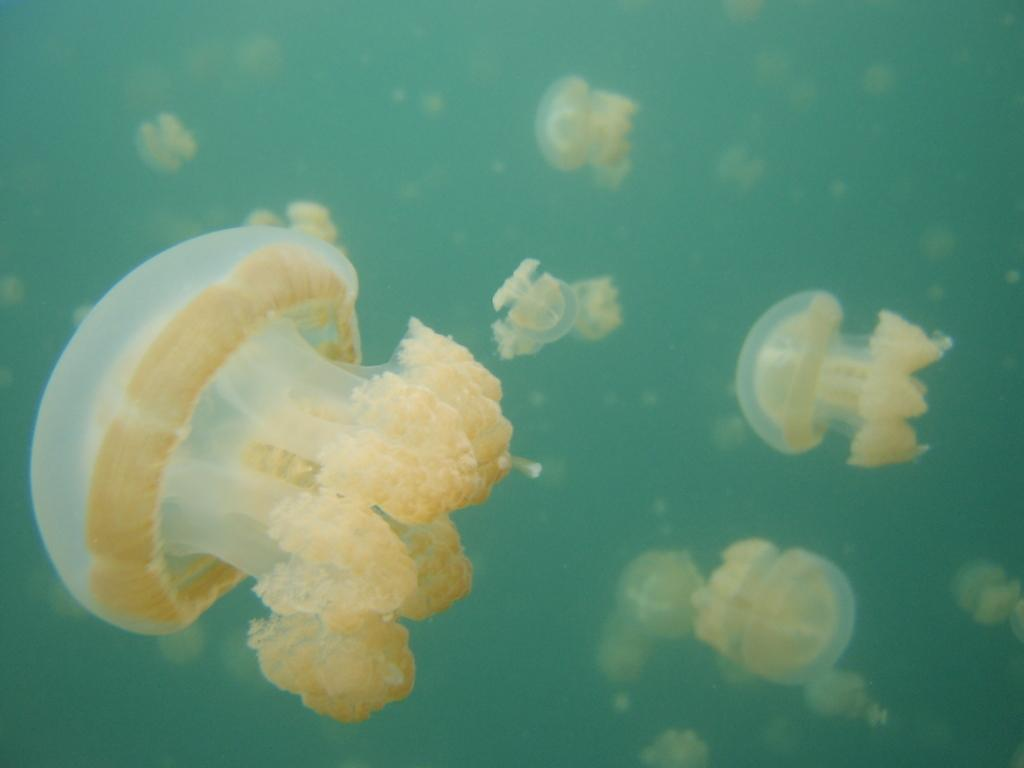What type of animals are in the image? There are jellyfish in the image. Where are the jellyfish located? The jellyfish are in the water. What type of circle can be seen in the image? There is no circle present in the image; it features jellyfish in the water. What does the goat have to do with the image? There is no goat present in the image; it features jellyfish in the water. 